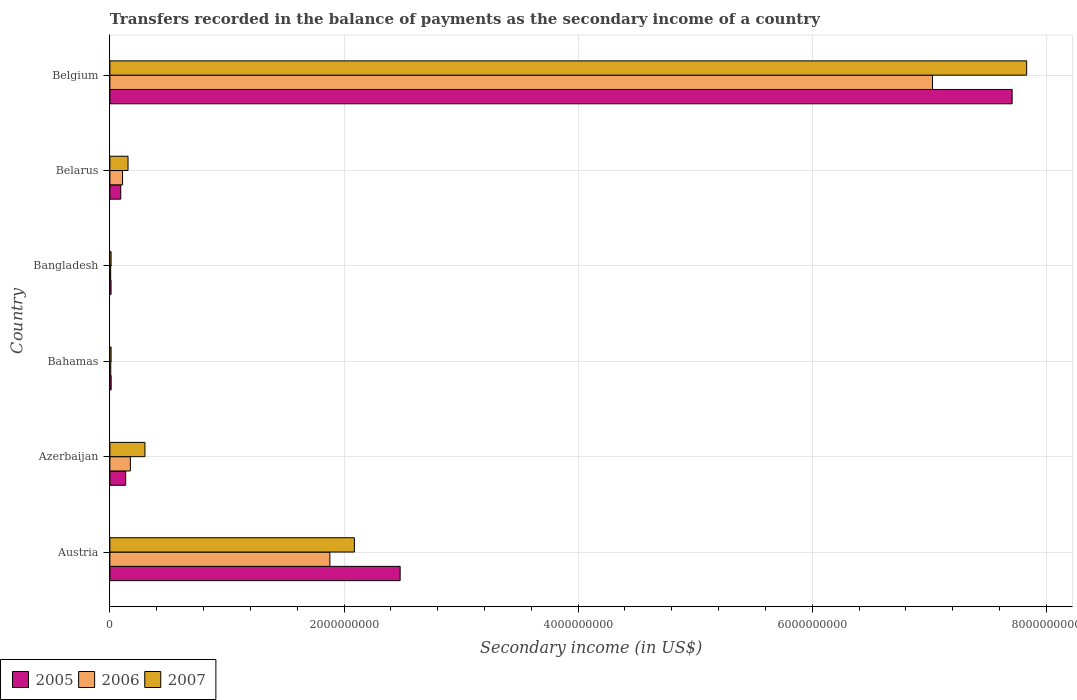Are the number of bars per tick equal to the number of legend labels?
Your answer should be compact. Yes. Are the number of bars on each tick of the Y-axis equal?
Give a very brief answer. Yes. How many bars are there on the 4th tick from the top?
Your answer should be compact. 3. What is the label of the 5th group of bars from the top?
Offer a terse response. Azerbaijan. What is the secondary income of in 2007 in Bahamas?
Give a very brief answer. 1.03e+07. Across all countries, what is the maximum secondary income of in 2007?
Make the answer very short. 7.83e+09. Across all countries, what is the minimum secondary income of in 2005?
Give a very brief answer. 9.91e+06. What is the total secondary income of in 2005 in the graph?
Provide a succinct answer. 1.04e+1. What is the difference between the secondary income of in 2005 in Austria and that in Azerbaijan?
Keep it short and to the point. 2.34e+09. What is the difference between the secondary income of in 2006 in Belarus and the secondary income of in 2007 in Austria?
Your answer should be very brief. -1.98e+09. What is the average secondary income of in 2007 per country?
Make the answer very short. 1.73e+09. What is the difference between the secondary income of in 2005 and secondary income of in 2006 in Belarus?
Ensure brevity in your answer.  -1.54e+07. What is the ratio of the secondary income of in 2006 in Austria to that in Belarus?
Give a very brief answer. 17.38. Is the secondary income of in 2007 in Austria less than that in Belarus?
Keep it short and to the point. No. What is the difference between the highest and the second highest secondary income of in 2007?
Ensure brevity in your answer.  5.74e+09. What is the difference between the highest and the lowest secondary income of in 2005?
Offer a terse response. 7.70e+09. Is it the case that in every country, the sum of the secondary income of in 2005 and secondary income of in 2006 is greater than the secondary income of in 2007?
Your answer should be very brief. Yes. How many bars are there?
Offer a very short reply. 18. Are all the bars in the graph horizontal?
Keep it short and to the point. Yes. What is the difference between two consecutive major ticks on the X-axis?
Offer a terse response. 2.00e+09. Does the graph contain grids?
Provide a short and direct response. Yes. What is the title of the graph?
Provide a succinct answer. Transfers recorded in the balance of payments as the secondary income of a country. Does "1999" appear as one of the legend labels in the graph?
Provide a succinct answer. No. What is the label or title of the X-axis?
Your response must be concise. Secondary income (in US$). What is the label or title of the Y-axis?
Make the answer very short. Country. What is the Secondary income (in US$) of 2005 in Austria?
Make the answer very short. 2.48e+09. What is the Secondary income (in US$) in 2006 in Austria?
Provide a short and direct response. 1.88e+09. What is the Secondary income (in US$) of 2007 in Austria?
Ensure brevity in your answer.  2.09e+09. What is the Secondary income (in US$) in 2005 in Azerbaijan?
Ensure brevity in your answer.  1.35e+08. What is the Secondary income (in US$) in 2006 in Azerbaijan?
Your response must be concise. 1.75e+08. What is the Secondary income (in US$) of 2007 in Azerbaijan?
Ensure brevity in your answer.  2.99e+08. What is the Secondary income (in US$) of 2005 in Bahamas?
Offer a very short reply. 1.08e+07. What is the Secondary income (in US$) of 2006 in Bahamas?
Provide a succinct answer. 7.49e+06. What is the Secondary income (in US$) of 2007 in Bahamas?
Make the answer very short. 1.03e+07. What is the Secondary income (in US$) in 2005 in Bangladesh?
Your answer should be compact. 9.91e+06. What is the Secondary income (in US$) of 2006 in Bangladesh?
Offer a terse response. 6.82e+06. What is the Secondary income (in US$) of 2007 in Bangladesh?
Your answer should be very brief. 1.01e+07. What is the Secondary income (in US$) in 2005 in Belarus?
Provide a succinct answer. 9.27e+07. What is the Secondary income (in US$) of 2006 in Belarus?
Offer a very short reply. 1.08e+08. What is the Secondary income (in US$) in 2007 in Belarus?
Keep it short and to the point. 1.55e+08. What is the Secondary income (in US$) of 2005 in Belgium?
Keep it short and to the point. 7.71e+09. What is the Secondary income (in US$) in 2006 in Belgium?
Your response must be concise. 7.03e+09. What is the Secondary income (in US$) of 2007 in Belgium?
Your response must be concise. 7.83e+09. Across all countries, what is the maximum Secondary income (in US$) in 2005?
Your answer should be compact. 7.71e+09. Across all countries, what is the maximum Secondary income (in US$) of 2006?
Your answer should be compact. 7.03e+09. Across all countries, what is the maximum Secondary income (in US$) of 2007?
Give a very brief answer. 7.83e+09. Across all countries, what is the minimum Secondary income (in US$) of 2005?
Provide a short and direct response. 9.91e+06. Across all countries, what is the minimum Secondary income (in US$) of 2006?
Provide a succinct answer. 6.82e+06. Across all countries, what is the minimum Secondary income (in US$) in 2007?
Keep it short and to the point. 1.01e+07. What is the total Secondary income (in US$) of 2005 in the graph?
Give a very brief answer. 1.04e+1. What is the total Secondary income (in US$) of 2006 in the graph?
Your answer should be very brief. 9.20e+09. What is the total Secondary income (in US$) of 2007 in the graph?
Offer a terse response. 1.04e+1. What is the difference between the Secondary income (in US$) of 2005 in Austria and that in Azerbaijan?
Keep it short and to the point. 2.34e+09. What is the difference between the Secondary income (in US$) of 2006 in Austria and that in Azerbaijan?
Offer a terse response. 1.70e+09. What is the difference between the Secondary income (in US$) of 2007 in Austria and that in Azerbaijan?
Offer a very short reply. 1.79e+09. What is the difference between the Secondary income (in US$) in 2005 in Austria and that in Bahamas?
Provide a short and direct response. 2.47e+09. What is the difference between the Secondary income (in US$) of 2006 in Austria and that in Bahamas?
Your answer should be very brief. 1.87e+09. What is the difference between the Secondary income (in US$) of 2007 in Austria and that in Bahamas?
Make the answer very short. 2.08e+09. What is the difference between the Secondary income (in US$) in 2005 in Austria and that in Bangladesh?
Offer a very short reply. 2.47e+09. What is the difference between the Secondary income (in US$) of 2006 in Austria and that in Bangladesh?
Offer a very short reply. 1.87e+09. What is the difference between the Secondary income (in US$) of 2007 in Austria and that in Bangladesh?
Ensure brevity in your answer.  2.08e+09. What is the difference between the Secondary income (in US$) in 2005 in Austria and that in Belarus?
Keep it short and to the point. 2.39e+09. What is the difference between the Secondary income (in US$) of 2006 in Austria and that in Belarus?
Provide a short and direct response. 1.77e+09. What is the difference between the Secondary income (in US$) of 2007 in Austria and that in Belarus?
Ensure brevity in your answer.  1.93e+09. What is the difference between the Secondary income (in US$) of 2005 in Austria and that in Belgium?
Your response must be concise. -5.23e+09. What is the difference between the Secondary income (in US$) in 2006 in Austria and that in Belgium?
Keep it short and to the point. -5.15e+09. What is the difference between the Secondary income (in US$) of 2007 in Austria and that in Belgium?
Provide a short and direct response. -5.74e+09. What is the difference between the Secondary income (in US$) of 2005 in Azerbaijan and that in Bahamas?
Provide a succinct answer. 1.24e+08. What is the difference between the Secondary income (in US$) of 2006 in Azerbaijan and that in Bahamas?
Provide a succinct answer. 1.67e+08. What is the difference between the Secondary income (in US$) of 2007 in Azerbaijan and that in Bahamas?
Your answer should be compact. 2.89e+08. What is the difference between the Secondary income (in US$) in 2005 in Azerbaijan and that in Bangladesh?
Ensure brevity in your answer.  1.25e+08. What is the difference between the Secondary income (in US$) of 2006 in Azerbaijan and that in Bangladesh?
Ensure brevity in your answer.  1.68e+08. What is the difference between the Secondary income (in US$) of 2007 in Azerbaijan and that in Bangladesh?
Your answer should be very brief. 2.89e+08. What is the difference between the Secondary income (in US$) of 2005 in Azerbaijan and that in Belarus?
Provide a short and direct response. 4.23e+07. What is the difference between the Secondary income (in US$) in 2006 in Azerbaijan and that in Belarus?
Make the answer very short. 6.67e+07. What is the difference between the Secondary income (in US$) in 2007 in Azerbaijan and that in Belarus?
Your answer should be very brief. 1.44e+08. What is the difference between the Secondary income (in US$) of 2005 in Azerbaijan and that in Belgium?
Your response must be concise. -7.57e+09. What is the difference between the Secondary income (in US$) in 2006 in Azerbaijan and that in Belgium?
Offer a very short reply. -6.85e+09. What is the difference between the Secondary income (in US$) of 2007 in Azerbaijan and that in Belgium?
Ensure brevity in your answer.  -7.53e+09. What is the difference between the Secondary income (in US$) of 2005 in Bahamas and that in Bangladesh?
Your answer should be compact. 8.77e+05. What is the difference between the Secondary income (in US$) in 2006 in Bahamas and that in Bangladesh?
Make the answer very short. 6.74e+05. What is the difference between the Secondary income (in US$) in 2007 in Bahamas and that in Bangladesh?
Make the answer very short. 2.30e+05. What is the difference between the Secondary income (in US$) of 2005 in Bahamas and that in Belarus?
Offer a very short reply. -8.19e+07. What is the difference between the Secondary income (in US$) in 2006 in Bahamas and that in Belarus?
Make the answer very short. -1.01e+08. What is the difference between the Secondary income (in US$) of 2007 in Bahamas and that in Belarus?
Ensure brevity in your answer.  -1.45e+08. What is the difference between the Secondary income (in US$) of 2005 in Bahamas and that in Belgium?
Give a very brief answer. -7.70e+09. What is the difference between the Secondary income (in US$) of 2006 in Bahamas and that in Belgium?
Give a very brief answer. -7.02e+09. What is the difference between the Secondary income (in US$) in 2007 in Bahamas and that in Belgium?
Offer a very short reply. -7.82e+09. What is the difference between the Secondary income (in US$) in 2005 in Bangladesh and that in Belarus?
Offer a terse response. -8.28e+07. What is the difference between the Secondary income (in US$) of 2006 in Bangladesh and that in Belarus?
Your answer should be very brief. -1.01e+08. What is the difference between the Secondary income (in US$) in 2007 in Bangladesh and that in Belarus?
Your answer should be compact. -1.45e+08. What is the difference between the Secondary income (in US$) of 2005 in Bangladesh and that in Belgium?
Provide a short and direct response. -7.70e+09. What is the difference between the Secondary income (in US$) of 2006 in Bangladesh and that in Belgium?
Give a very brief answer. -7.02e+09. What is the difference between the Secondary income (in US$) of 2007 in Bangladesh and that in Belgium?
Make the answer very short. -7.82e+09. What is the difference between the Secondary income (in US$) of 2005 in Belarus and that in Belgium?
Your response must be concise. -7.61e+09. What is the difference between the Secondary income (in US$) in 2006 in Belarus and that in Belgium?
Provide a short and direct response. -6.92e+09. What is the difference between the Secondary income (in US$) in 2007 in Belarus and that in Belgium?
Keep it short and to the point. -7.68e+09. What is the difference between the Secondary income (in US$) in 2005 in Austria and the Secondary income (in US$) in 2006 in Azerbaijan?
Offer a very short reply. 2.30e+09. What is the difference between the Secondary income (in US$) of 2005 in Austria and the Secondary income (in US$) of 2007 in Azerbaijan?
Provide a short and direct response. 2.18e+09. What is the difference between the Secondary income (in US$) of 2006 in Austria and the Secondary income (in US$) of 2007 in Azerbaijan?
Your response must be concise. 1.58e+09. What is the difference between the Secondary income (in US$) of 2005 in Austria and the Secondary income (in US$) of 2006 in Bahamas?
Ensure brevity in your answer.  2.47e+09. What is the difference between the Secondary income (in US$) of 2005 in Austria and the Secondary income (in US$) of 2007 in Bahamas?
Your response must be concise. 2.47e+09. What is the difference between the Secondary income (in US$) in 2006 in Austria and the Secondary income (in US$) in 2007 in Bahamas?
Offer a very short reply. 1.87e+09. What is the difference between the Secondary income (in US$) in 2005 in Austria and the Secondary income (in US$) in 2006 in Bangladesh?
Offer a very short reply. 2.47e+09. What is the difference between the Secondary income (in US$) of 2005 in Austria and the Secondary income (in US$) of 2007 in Bangladesh?
Keep it short and to the point. 2.47e+09. What is the difference between the Secondary income (in US$) in 2006 in Austria and the Secondary income (in US$) in 2007 in Bangladesh?
Make the answer very short. 1.87e+09. What is the difference between the Secondary income (in US$) in 2005 in Austria and the Secondary income (in US$) in 2006 in Belarus?
Provide a succinct answer. 2.37e+09. What is the difference between the Secondary income (in US$) in 2005 in Austria and the Secondary income (in US$) in 2007 in Belarus?
Provide a succinct answer. 2.32e+09. What is the difference between the Secondary income (in US$) of 2006 in Austria and the Secondary income (in US$) of 2007 in Belarus?
Make the answer very short. 1.72e+09. What is the difference between the Secondary income (in US$) in 2005 in Austria and the Secondary income (in US$) in 2006 in Belgium?
Make the answer very short. -4.55e+09. What is the difference between the Secondary income (in US$) of 2005 in Austria and the Secondary income (in US$) of 2007 in Belgium?
Keep it short and to the point. -5.35e+09. What is the difference between the Secondary income (in US$) of 2006 in Austria and the Secondary income (in US$) of 2007 in Belgium?
Provide a short and direct response. -5.95e+09. What is the difference between the Secondary income (in US$) in 2005 in Azerbaijan and the Secondary income (in US$) in 2006 in Bahamas?
Your answer should be very brief. 1.28e+08. What is the difference between the Secondary income (in US$) of 2005 in Azerbaijan and the Secondary income (in US$) of 2007 in Bahamas?
Keep it short and to the point. 1.25e+08. What is the difference between the Secondary income (in US$) of 2006 in Azerbaijan and the Secondary income (in US$) of 2007 in Bahamas?
Make the answer very short. 1.64e+08. What is the difference between the Secondary income (in US$) in 2005 in Azerbaijan and the Secondary income (in US$) in 2006 in Bangladesh?
Your response must be concise. 1.28e+08. What is the difference between the Secondary income (in US$) in 2005 in Azerbaijan and the Secondary income (in US$) in 2007 in Bangladesh?
Your answer should be very brief. 1.25e+08. What is the difference between the Secondary income (in US$) in 2006 in Azerbaijan and the Secondary income (in US$) in 2007 in Bangladesh?
Your answer should be compact. 1.65e+08. What is the difference between the Secondary income (in US$) in 2005 in Azerbaijan and the Secondary income (in US$) in 2006 in Belarus?
Give a very brief answer. 2.69e+07. What is the difference between the Secondary income (in US$) in 2005 in Azerbaijan and the Secondary income (in US$) in 2007 in Belarus?
Offer a terse response. -2.00e+07. What is the difference between the Secondary income (in US$) in 2006 in Azerbaijan and the Secondary income (in US$) in 2007 in Belarus?
Your response must be concise. 1.98e+07. What is the difference between the Secondary income (in US$) in 2005 in Azerbaijan and the Secondary income (in US$) in 2006 in Belgium?
Provide a succinct answer. -6.89e+09. What is the difference between the Secondary income (in US$) of 2005 in Azerbaijan and the Secondary income (in US$) of 2007 in Belgium?
Keep it short and to the point. -7.70e+09. What is the difference between the Secondary income (in US$) in 2006 in Azerbaijan and the Secondary income (in US$) in 2007 in Belgium?
Your answer should be very brief. -7.66e+09. What is the difference between the Secondary income (in US$) in 2005 in Bahamas and the Secondary income (in US$) in 2006 in Bangladesh?
Offer a very short reply. 3.97e+06. What is the difference between the Secondary income (in US$) of 2005 in Bahamas and the Secondary income (in US$) of 2007 in Bangladesh?
Offer a very short reply. 7.06e+05. What is the difference between the Secondary income (in US$) in 2006 in Bahamas and the Secondary income (in US$) in 2007 in Bangladesh?
Your response must be concise. -2.59e+06. What is the difference between the Secondary income (in US$) in 2005 in Bahamas and the Secondary income (in US$) in 2006 in Belarus?
Ensure brevity in your answer.  -9.73e+07. What is the difference between the Secondary income (in US$) in 2005 in Bahamas and the Secondary income (in US$) in 2007 in Belarus?
Your answer should be very brief. -1.44e+08. What is the difference between the Secondary income (in US$) of 2006 in Bahamas and the Secondary income (in US$) of 2007 in Belarus?
Keep it short and to the point. -1.48e+08. What is the difference between the Secondary income (in US$) of 2005 in Bahamas and the Secondary income (in US$) of 2006 in Belgium?
Offer a terse response. -7.02e+09. What is the difference between the Secondary income (in US$) in 2005 in Bahamas and the Secondary income (in US$) in 2007 in Belgium?
Make the answer very short. -7.82e+09. What is the difference between the Secondary income (in US$) in 2006 in Bahamas and the Secondary income (in US$) in 2007 in Belgium?
Give a very brief answer. -7.82e+09. What is the difference between the Secondary income (in US$) of 2005 in Bangladesh and the Secondary income (in US$) of 2006 in Belarus?
Your response must be concise. -9.82e+07. What is the difference between the Secondary income (in US$) in 2005 in Bangladesh and the Secondary income (in US$) in 2007 in Belarus?
Ensure brevity in your answer.  -1.45e+08. What is the difference between the Secondary income (in US$) in 2006 in Bangladesh and the Secondary income (in US$) in 2007 in Belarus?
Make the answer very short. -1.48e+08. What is the difference between the Secondary income (in US$) in 2005 in Bangladesh and the Secondary income (in US$) in 2006 in Belgium?
Give a very brief answer. -7.02e+09. What is the difference between the Secondary income (in US$) in 2005 in Bangladesh and the Secondary income (in US$) in 2007 in Belgium?
Provide a succinct answer. -7.82e+09. What is the difference between the Secondary income (in US$) of 2006 in Bangladesh and the Secondary income (in US$) of 2007 in Belgium?
Keep it short and to the point. -7.82e+09. What is the difference between the Secondary income (in US$) of 2005 in Belarus and the Secondary income (in US$) of 2006 in Belgium?
Your answer should be very brief. -6.93e+09. What is the difference between the Secondary income (in US$) in 2005 in Belarus and the Secondary income (in US$) in 2007 in Belgium?
Your response must be concise. -7.74e+09. What is the difference between the Secondary income (in US$) in 2006 in Belarus and the Secondary income (in US$) in 2007 in Belgium?
Provide a succinct answer. -7.72e+09. What is the average Secondary income (in US$) of 2005 per country?
Offer a very short reply. 1.74e+09. What is the average Secondary income (in US$) in 2006 per country?
Offer a very short reply. 1.53e+09. What is the average Secondary income (in US$) in 2007 per country?
Make the answer very short. 1.73e+09. What is the difference between the Secondary income (in US$) of 2005 and Secondary income (in US$) of 2006 in Austria?
Ensure brevity in your answer.  6.00e+08. What is the difference between the Secondary income (in US$) of 2005 and Secondary income (in US$) of 2007 in Austria?
Give a very brief answer. 3.91e+08. What is the difference between the Secondary income (in US$) in 2006 and Secondary income (in US$) in 2007 in Austria?
Keep it short and to the point. -2.09e+08. What is the difference between the Secondary income (in US$) of 2005 and Secondary income (in US$) of 2006 in Azerbaijan?
Offer a terse response. -3.98e+07. What is the difference between the Secondary income (in US$) in 2005 and Secondary income (in US$) in 2007 in Azerbaijan?
Offer a terse response. -1.64e+08. What is the difference between the Secondary income (in US$) of 2006 and Secondary income (in US$) of 2007 in Azerbaijan?
Give a very brief answer. -1.25e+08. What is the difference between the Secondary income (in US$) in 2005 and Secondary income (in US$) in 2006 in Bahamas?
Offer a very short reply. 3.30e+06. What is the difference between the Secondary income (in US$) in 2005 and Secondary income (in US$) in 2007 in Bahamas?
Offer a terse response. 4.76e+05. What is the difference between the Secondary income (in US$) in 2006 and Secondary income (in US$) in 2007 in Bahamas?
Your answer should be very brief. -2.82e+06. What is the difference between the Secondary income (in US$) of 2005 and Secondary income (in US$) of 2006 in Bangladesh?
Provide a short and direct response. 3.09e+06. What is the difference between the Secondary income (in US$) of 2005 and Secondary income (in US$) of 2007 in Bangladesh?
Offer a very short reply. -1.71e+05. What is the difference between the Secondary income (in US$) of 2006 and Secondary income (in US$) of 2007 in Bangladesh?
Offer a terse response. -3.26e+06. What is the difference between the Secondary income (in US$) of 2005 and Secondary income (in US$) of 2006 in Belarus?
Offer a terse response. -1.54e+07. What is the difference between the Secondary income (in US$) of 2005 and Secondary income (in US$) of 2007 in Belarus?
Your answer should be very brief. -6.23e+07. What is the difference between the Secondary income (in US$) of 2006 and Secondary income (in US$) of 2007 in Belarus?
Keep it short and to the point. -4.69e+07. What is the difference between the Secondary income (in US$) of 2005 and Secondary income (in US$) of 2006 in Belgium?
Your answer should be very brief. 6.80e+08. What is the difference between the Secondary income (in US$) of 2005 and Secondary income (in US$) of 2007 in Belgium?
Offer a terse response. -1.24e+08. What is the difference between the Secondary income (in US$) in 2006 and Secondary income (in US$) in 2007 in Belgium?
Your response must be concise. -8.04e+08. What is the ratio of the Secondary income (in US$) of 2005 in Austria to that in Azerbaijan?
Your response must be concise. 18.36. What is the ratio of the Secondary income (in US$) in 2006 in Austria to that in Azerbaijan?
Your response must be concise. 10.75. What is the ratio of the Secondary income (in US$) of 2007 in Austria to that in Azerbaijan?
Your answer should be compact. 6.97. What is the ratio of the Secondary income (in US$) in 2005 in Austria to that in Bahamas?
Give a very brief answer. 229.87. What is the ratio of the Secondary income (in US$) in 2006 in Austria to that in Bahamas?
Provide a short and direct response. 250.88. What is the ratio of the Secondary income (in US$) in 2007 in Austria to that in Bahamas?
Make the answer very short. 202.57. What is the ratio of the Secondary income (in US$) in 2005 in Austria to that in Bangladesh?
Keep it short and to the point. 250.21. What is the ratio of the Secondary income (in US$) of 2006 in Austria to that in Bangladesh?
Ensure brevity in your answer.  275.69. What is the ratio of the Secondary income (in US$) of 2007 in Austria to that in Bangladesh?
Provide a succinct answer. 207.18. What is the ratio of the Secondary income (in US$) in 2005 in Austria to that in Belarus?
Offer a very short reply. 26.75. What is the ratio of the Secondary income (in US$) of 2006 in Austria to that in Belarus?
Your response must be concise. 17.38. What is the ratio of the Secondary income (in US$) of 2007 in Austria to that in Belarus?
Give a very brief answer. 13.47. What is the ratio of the Secondary income (in US$) of 2005 in Austria to that in Belgium?
Ensure brevity in your answer.  0.32. What is the ratio of the Secondary income (in US$) in 2006 in Austria to that in Belgium?
Ensure brevity in your answer.  0.27. What is the ratio of the Secondary income (in US$) in 2007 in Austria to that in Belgium?
Your answer should be compact. 0.27. What is the ratio of the Secondary income (in US$) in 2005 in Azerbaijan to that in Bahamas?
Offer a terse response. 12.52. What is the ratio of the Secondary income (in US$) in 2006 in Azerbaijan to that in Bahamas?
Offer a terse response. 23.34. What is the ratio of the Secondary income (in US$) in 2007 in Azerbaijan to that in Bahamas?
Your answer should be compact. 29.04. What is the ratio of the Secondary income (in US$) of 2005 in Azerbaijan to that in Bangladesh?
Give a very brief answer. 13.63. What is the ratio of the Secondary income (in US$) of 2006 in Azerbaijan to that in Bangladesh?
Give a very brief answer. 25.65. What is the ratio of the Secondary income (in US$) of 2007 in Azerbaijan to that in Bangladesh?
Give a very brief answer. 29.7. What is the ratio of the Secondary income (in US$) of 2005 in Azerbaijan to that in Belarus?
Offer a terse response. 1.46. What is the ratio of the Secondary income (in US$) of 2006 in Azerbaijan to that in Belarus?
Provide a short and direct response. 1.62. What is the ratio of the Secondary income (in US$) of 2007 in Azerbaijan to that in Belarus?
Make the answer very short. 1.93. What is the ratio of the Secondary income (in US$) of 2005 in Azerbaijan to that in Belgium?
Offer a very short reply. 0.02. What is the ratio of the Secondary income (in US$) in 2006 in Azerbaijan to that in Belgium?
Offer a terse response. 0.02. What is the ratio of the Secondary income (in US$) in 2007 in Azerbaijan to that in Belgium?
Give a very brief answer. 0.04. What is the ratio of the Secondary income (in US$) of 2005 in Bahamas to that in Bangladesh?
Your response must be concise. 1.09. What is the ratio of the Secondary income (in US$) of 2006 in Bahamas to that in Bangladesh?
Make the answer very short. 1.1. What is the ratio of the Secondary income (in US$) in 2007 in Bahamas to that in Bangladesh?
Your answer should be compact. 1.02. What is the ratio of the Secondary income (in US$) in 2005 in Bahamas to that in Belarus?
Ensure brevity in your answer.  0.12. What is the ratio of the Secondary income (in US$) of 2006 in Bahamas to that in Belarus?
Your answer should be very brief. 0.07. What is the ratio of the Secondary income (in US$) in 2007 in Bahamas to that in Belarus?
Ensure brevity in your answer.  0.07. What is the ratio of the Secondary income (in US$) in 2005 in Bahamas to that in Belgium?
Provide a succinct answer. 0. What is the ratio of the Secondary income (in US$) in 2006 in Bahamas to that in Belgium?
Offer a terse response. 0. What is the ratio of the Secondary income (in US$) of 2007 in Bahamas to that in Belgium?
Ensure brevity in your answer.  0. What is the ratio of the Secondary income (in US$) of 2005 in Bangladesh to that in Belarus?
Offer a very short reply. 0.11. What is the ratio of the Secondary income (in US$) in 2006 in Bangladesh to that in Belarus?
Ensure brevity in your answer.  0.06. What is the ratio of the Secondary income (in US$) in 2007 in Bangladesh to that in Belarus?
Provide a short and direct response. 0.07. What is the ratio of the Secondary income (in US$) in 2005 in Bangladesh to that in Belgium?
Ensure brevity in your answer.  0. What is the ratio of the Secondary income (in US$) in 2006 in Bangladesh to that in Belgium?
Your answer should be very brief. 0. What is the ratio of the Secondary income (in US$) in 2007 in Bangladesh to that in Belgium?
Offer a very short reply. 0. What is the ratio of the Secondary income (in US$) in 2005 in Belarus to that in Belgium?
Keep it short and to the point. 0.01. What is the ratio of the Secondary income (in US$) in 2006 in Belarus to that in Belgium?
Provide a succinct answer. 0.02. What is the ratio of the Secondary income (in US$) in 2007 in Belarus to that in Belgium?
Provide a succinct answer. 0.02. What is the difference between the highest and the second highest Secondary income (in US$) in 2005?
Ensure brevity in your answer.  5.23e+09. What is the difference between the highest and the second highest Secondary income (in US$) in 2006?
Keep it short and to the point. 5.15e+09. What is the difference between the highest and the second highest Secondary income (in US$) in 2007?
Provide a succinct answer. 5.74e+09. What is the difference between the highest and the lowest Secondary income (in US$) in 2005?
Offer a very short reply. 7.70e+09. What is the difference between the highest and the lowest Secondary income (in US$) of 2006?
Keep it short and to the point. 7.02e+09. What is the difference between the highest and the lowest Secondary income (in US$) in 2007?
Provide a succinct answer. 7.82e+09. 